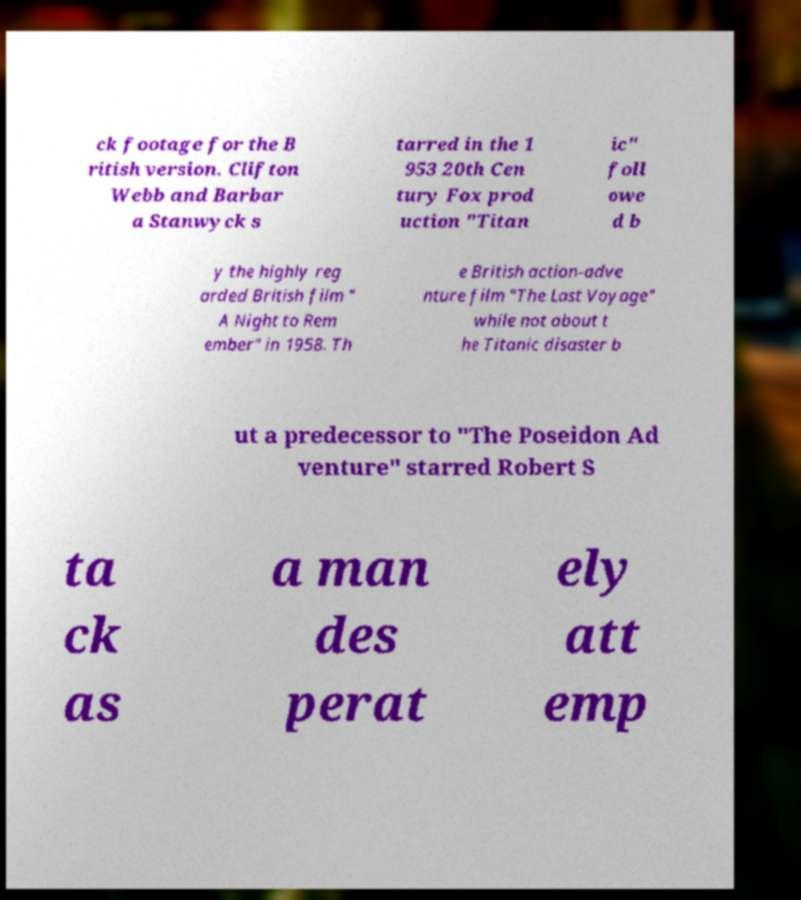What messages or text are displayed in this image? I need them in a readable, typed format. ck footage for the B ritish version. Clifton Webb and Barbar a Stanwyck s tarred in the 1 953 20th Cen tury Fox prod uction "Titan ic" foll owe d b y the highly reg arded British film " A Night to Rem ember" in 1958. Th e British action-adve nture film "The Last Voyage" while not about t he Titanic disaster b ut a predecessor to "The Poseidon Ad venture" starred Robert S ta ck as a man des perat ely att emp 